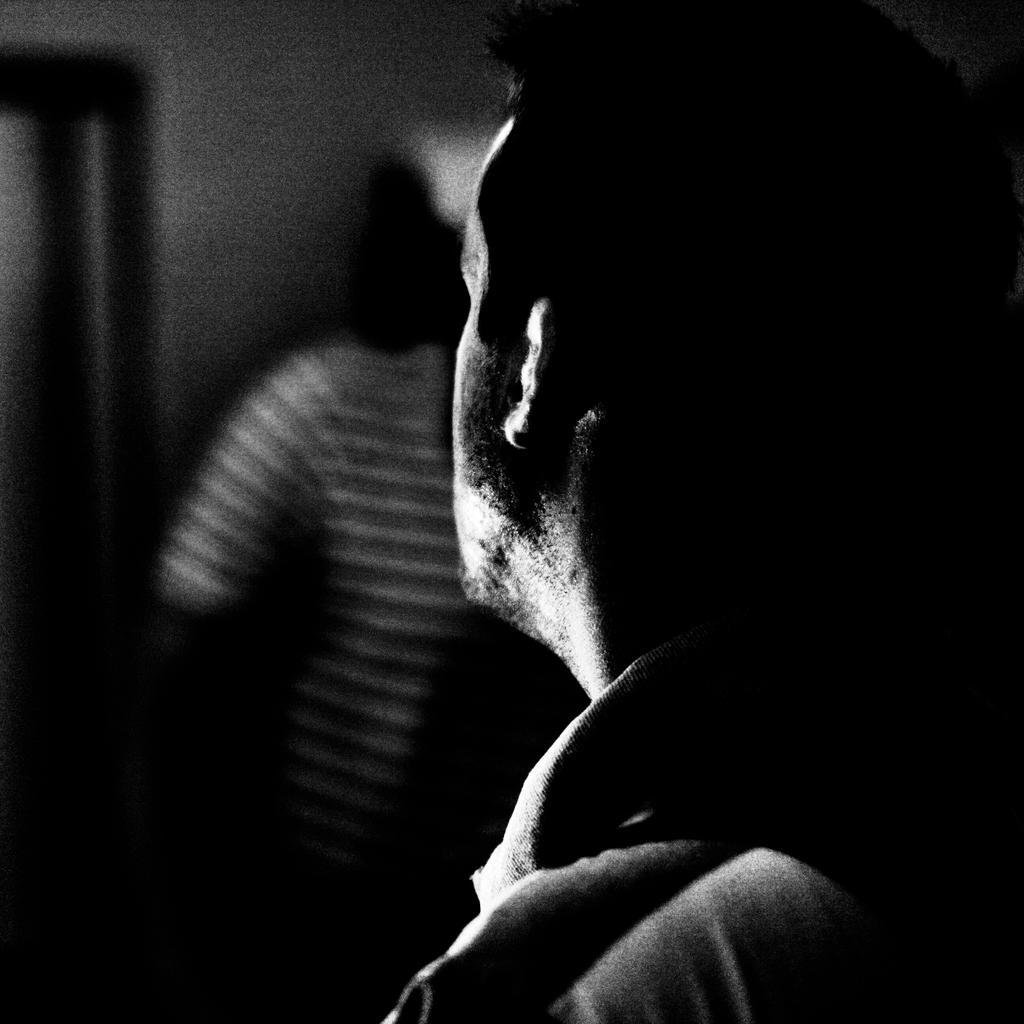What is the color scheme of the picture? The picture is black and white. Can you describe the main subject in the image? There is a man in the picture. What can be observed about the background of the image? The background of the picture is blurry. What type of bone can be seen in the picture? There is no bone present in the picture; it features a man in a black and white image with a blurry background. 